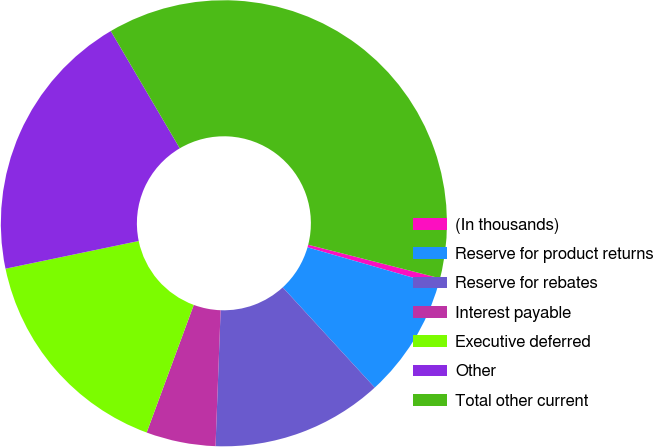Convert chart. <chart><loc_0><loc_0><loc_500><loc_500><pie_chart><fcel>(In thousands)<fcel>Reserve for product returns<fcel>Reserve for rebates<fcel>Interest payable<fcel>Executive deferred<fcel>Other<fcel>Total other current<nl><fcel>0.49%<fcel>8.72%<fcel>12.42%<fcel>5.03%<fcel>16.11%<fcel>19.8%<fcel>37.43%<nl></chart> 